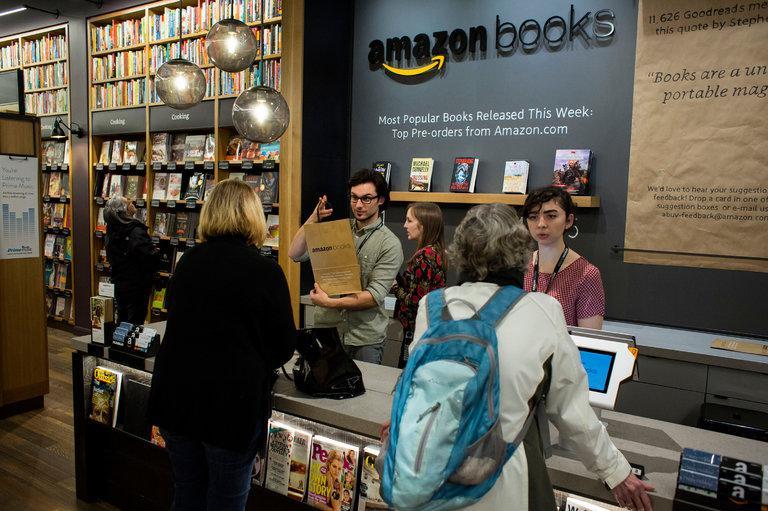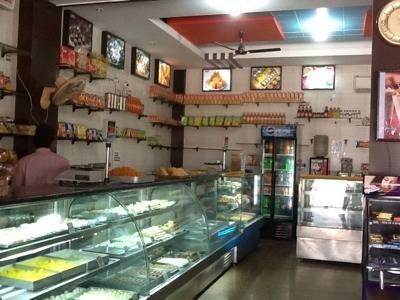The first image is the image on the left, the second image is the image on the right. For the images shown, is this caption "Contains a photo of the book store from outside the shop." true? Answer yes or no. No. The first image is the image on the left, the second image is the image on the right. Considering the images on both sides, is "Two images on the left show the outside store front of a book shop." valid? Answer yes or no. No. 